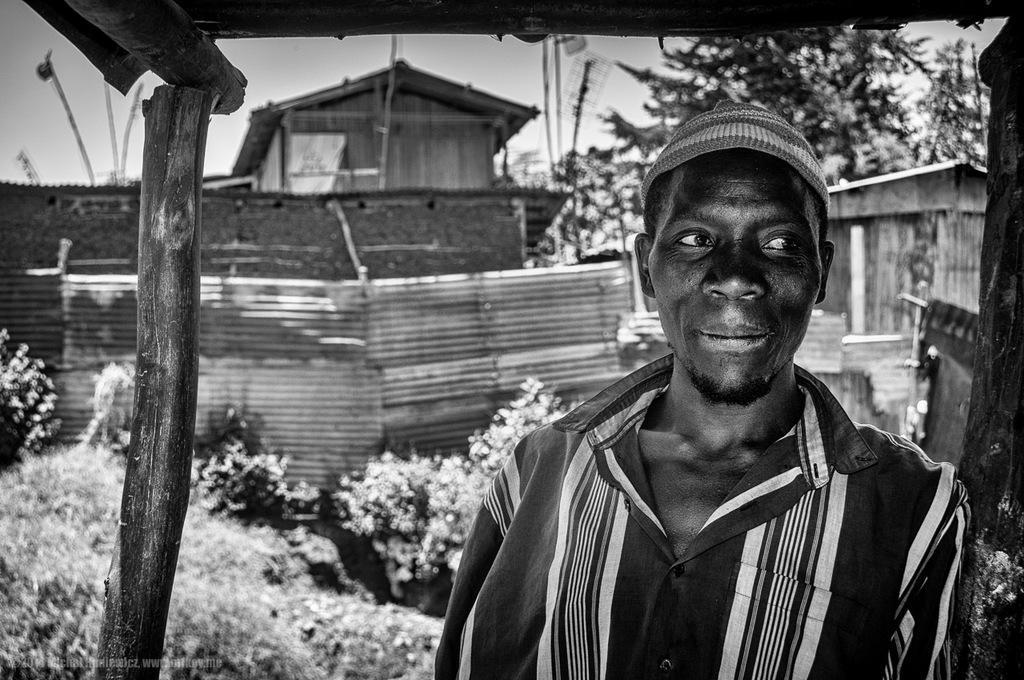Could you give a brief overview of what you see in this image? In this image in the foreground a person wearing a cap might be visible on tent , there are wooden sticks visible in the middle , backside of person there are tent houses, fence, plants,trees and the sky visible 